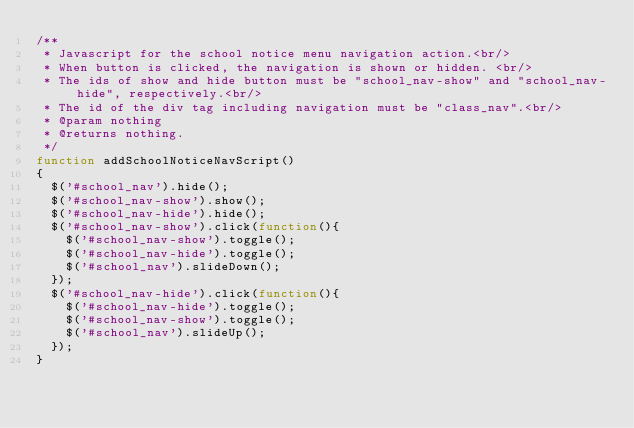<code> <loc_0><loc_0><loc_500><loc_500><_JavaScript_>/**
 * Javascript for the school notice menu navigation action.<br/>
 * When button is clicked, the navigation is shown or hidden. <br/>
 * The ids of show and hide button must be "school_nav-show" and "school_nav-hide", respectively.<br/>
 * The id of the div tag including navigation must be "class_nav".<br/>
 * @param nothing
 * @returns nothing.
 */
function addSchoolNoticeNavScript()
{
	$('#school_nav').hide();
	$('#school_nav-show').show();
	$('#school_nav-hide').hide();
	$('#school_nav-show').click(function(){
		$('#school_nav-show').toggle();
		$('#school_nav-hide').toggle();
		$('#school_nav').slideDown();
	});
	$('#school_nav-hide').click(function(){
		$('#school_nav-hide').toggle();
		$('#school_nav-show').toggle();
		$('#school_nav').slideUp();
	});
}	</code> 